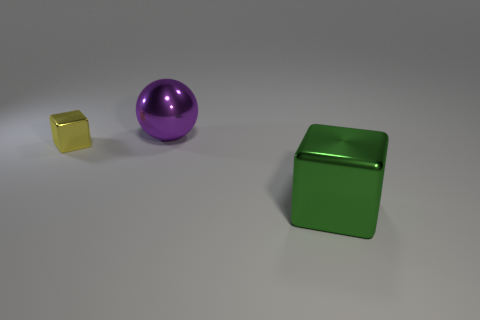The purple ball has what size?
Make the answer very short. Large. There is a yellow object; what number of tiny yellow cubes are left of it?
Provide a short and direct response. 0. What is the size of the other metal object that is the same shape as the yellow metal object?
Your answer should be compact. Large. There is a metallic object that is both in front of the metallic ball and to the right of the small yellow object; how big is it?
Give a very brief answer. Large. How many yellow objects are small shiny objects or metallic blocks?
Your answer should be compact. 1. The large purple metallic thing is what shape?
Ensure brevity in your answer.  Sphere. How many other things are there of the same shape as the big purple object?
Offer a terse response. 0. The metal cube that is on the left side of the large cube is what color?
Ensure brevity in your answer.  Yellow. Do the yellow object and the large green block have the same material?
Your answer should be very brief. Yes. What number of things are either balls or things on the left side of the big purple metal object?
Make the answer very short. 2. 